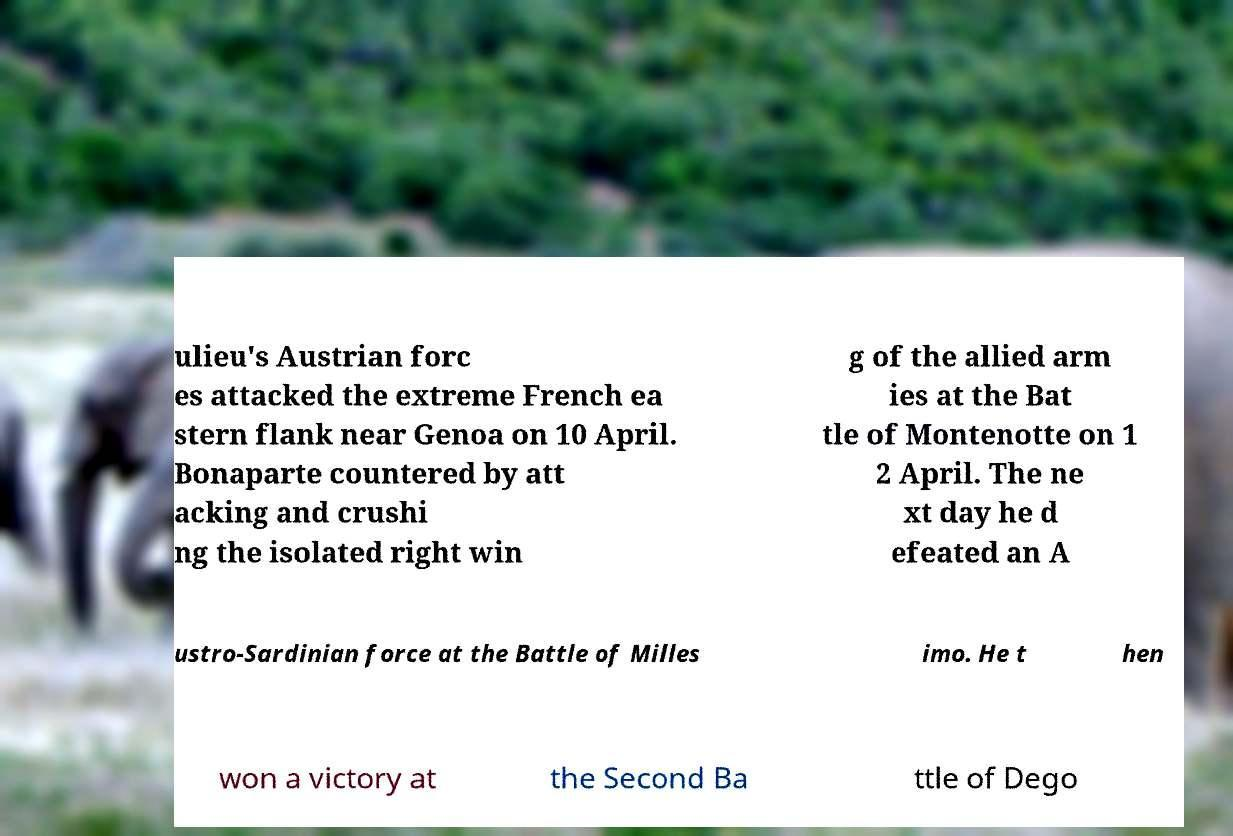Please read and relay the text visible in this image. What does it say? ulieu's Austrian forc es attacked the extreme French ea stern flank near Genoa on 10 April. Bonaparte countered by att acking and crushi ng the isolated right win g of the allied arm ies at the Bat tle of Montenotte on 1 2 April. The ne xt day he d efeated an A ustro-Sardinian force at the Battle of Milles imo. He t hen won a victory at the Second Ba ttle of Dego 